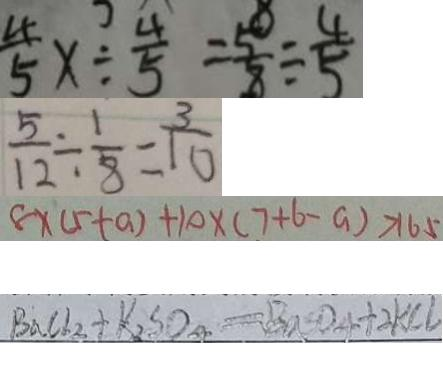Convert formula to latex. <formula><loc_0><loc_0><loc_500><loc_500>\frac { 4 } { 5 } x \div \frac { 4 } { 5 } = \frac { 5 } { 8 } \div \frac { 4 } { 5 } 
 \frac { 5 } { 1 2 } \div \frac { 1 } { 8 } = \frac { 3 } { 1 0 } 
 8 \times ( 5 + a ) + 1 0 \times ( 7 + 6 - a ) > 1 6 5 
 B a C l _ { 2 } + K _ { 2 } S O _ { 4 } = B a S O _ { 4 } + 2 K C l</formula> 